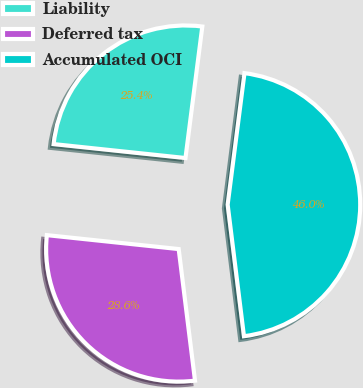Convert chart. <chart><loc_0><loc_0><loc_500><loc_500><pie_chart><fcel>Liability<fcel>Deferred tax<fcel>Accumulated OCI<nl><fcel>25.35%<fcel>28.64%<fcel>46.01%<nl></chart> 